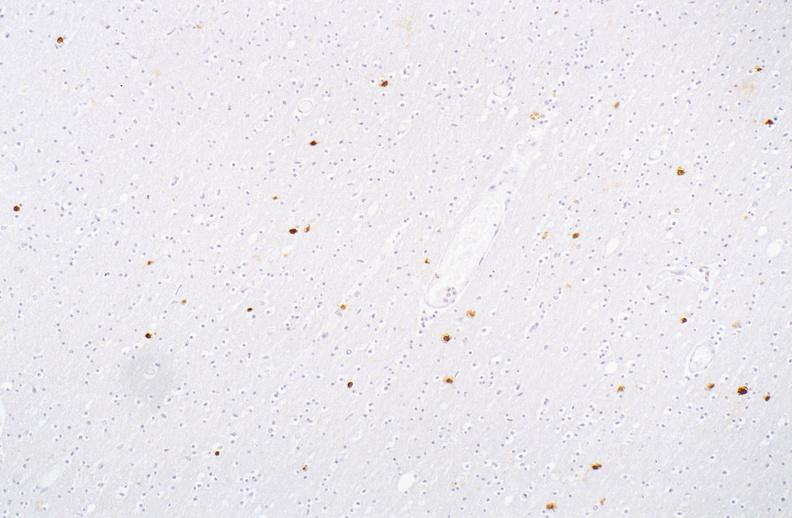does the superior vena cava show herpes simplex virus, brain, immunohistochemistry?
Answer the question using a single word or phrase. No 